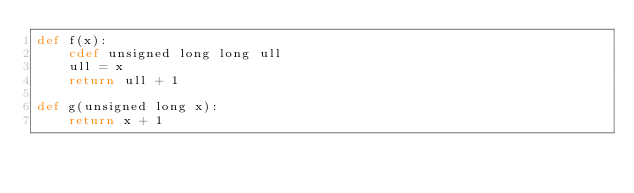Convert code to text. <code><loc_0><loc_0><loc_500><loc_500><_Cython_>def f(x):
	cdef unsigned long long ull
	ull = x
	return ull + 1

def g(unsigned long x):
	return x + 1
</code> 